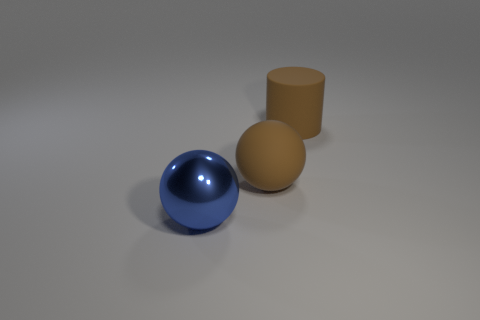Is the big rubber cylinder the same color as the rubber sphere?
Provide a short and direct response. Yes. There is a big matte object that is on the left side of the cylinder; does it have the same shape as the large object that is behind the brown sphere?
Your answer should be compact. No. There is another object that is the same shape as the blue thing; what is it made of?
Your answer should be compact. Rubber. The big thing that is both to the left of the brown cylinder and right of the metallic object is what color?
Ensure brevity in your answer.  Brown. There is a thing that is on the right side of the matte object that is in front of the large brown rubber cylinder; is there a brown thing that is left of it?
Your response must be concise. Yes. How many objects are large metallic things or big green matte objects?
Your answer should be compact. 1. Is the material of the large cylinder the same as the ball that is behind the big metal ball?
Your response must be concise. Yes. Is there any other thing that has the same color as the metal thing?
Offer a terse response. No. How many objects are either big brown things that are behind the large brown sphere or large brown cylinders behind the blue object?
Your answer should be compact. 1. The big object that is both to the left of the brown rubber cylinder and on the right side of the metallic thing has what shape?
Provide a succinct answer. Sphere. 